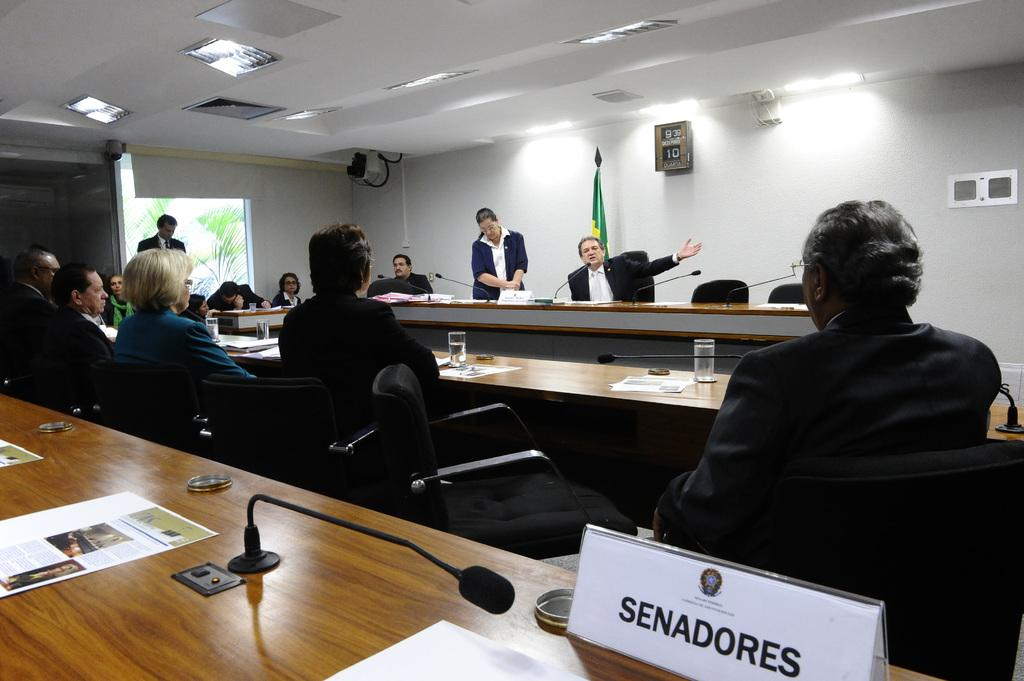<image>
Present a compact description of the photo's key features. People, including Senadores, are sitting at long tables watching a presentation. 